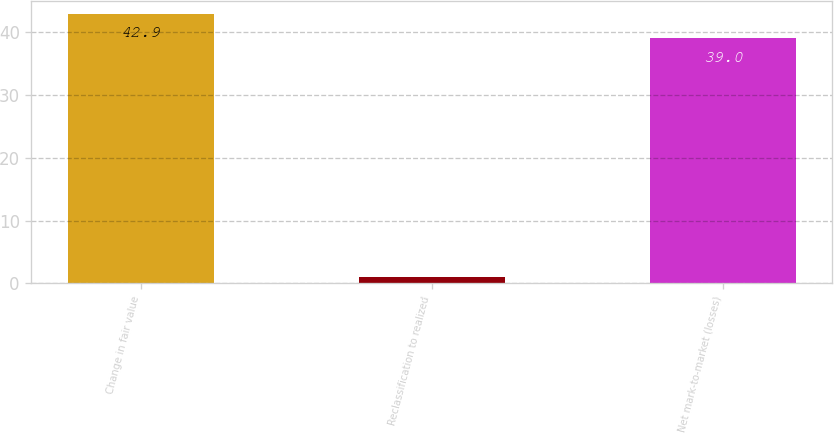Convert chart to OTSL. <chart><loc_0><loc_0><loc_500><loc_500><bar_chart><fcel>Change in fair value<fcel>Reclassification to realized<fcel>Net mark-to-market (losses)<nl><fcel>42.9<fcel>1<fcel>39<nl></chart> 